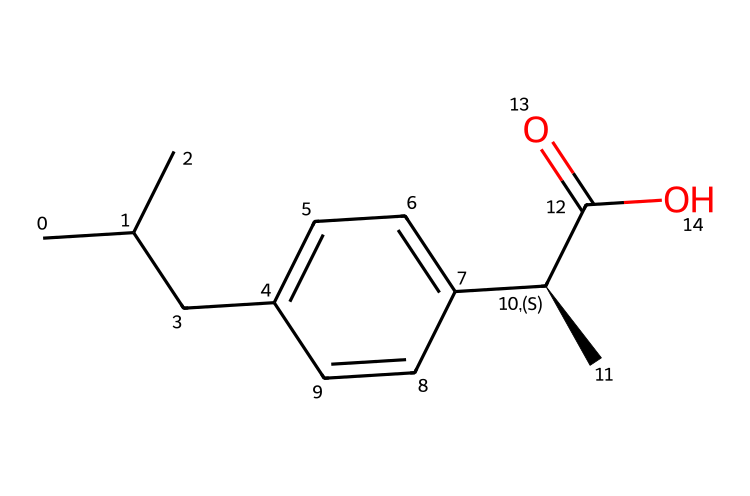What is the common name of the compound represented by this SMILES? The SMILES given corresponds to ibuprofen, which is a well-known nonsteroidal anti-inflammatory drug (NSAID) commonly used as a pain reliever and anti-inflammatory agent.
Answer: ibuprofen How many carbon atoms are present in the molecular structure? By analyzing the structure represented in the SMILES, we can count the number of carbon (C) symbols: there are 13 carbon atoms in the entire structure.
Answer: 13 What functional group is present in ibuprofen? The SMILES indicates the presence of a carboxylic acid functional group (-COOH, indicated by C(=O)O) at the end of the molecule, which is characteristic of this compound.
Answer: carboxylic acid What is the degree of saturation in the molecular structure? The degree of saturation can be determined by counting the number of rings and double bonds in the structure. The SMILES indicates there are no rings but one double bond (the carbonyl group), resulting in a moderate degree of saturation.
Answer: 1 Is ibuprofen classified as an acidic or basic compound? The presence of the carboxylic acid group contributes to the acidity of the compound, making ibuprofen classified as an acidic compound.
Answer: acidic What is the stereochemistry around the chiral center in ibuprofen? The chiral center is indicated by the @ symbol in the SMILES, meaning there is a specific three-dimensional arrangement around that carbon atom. The (C) that follows indicates the configuration.
Answer: S configuration 